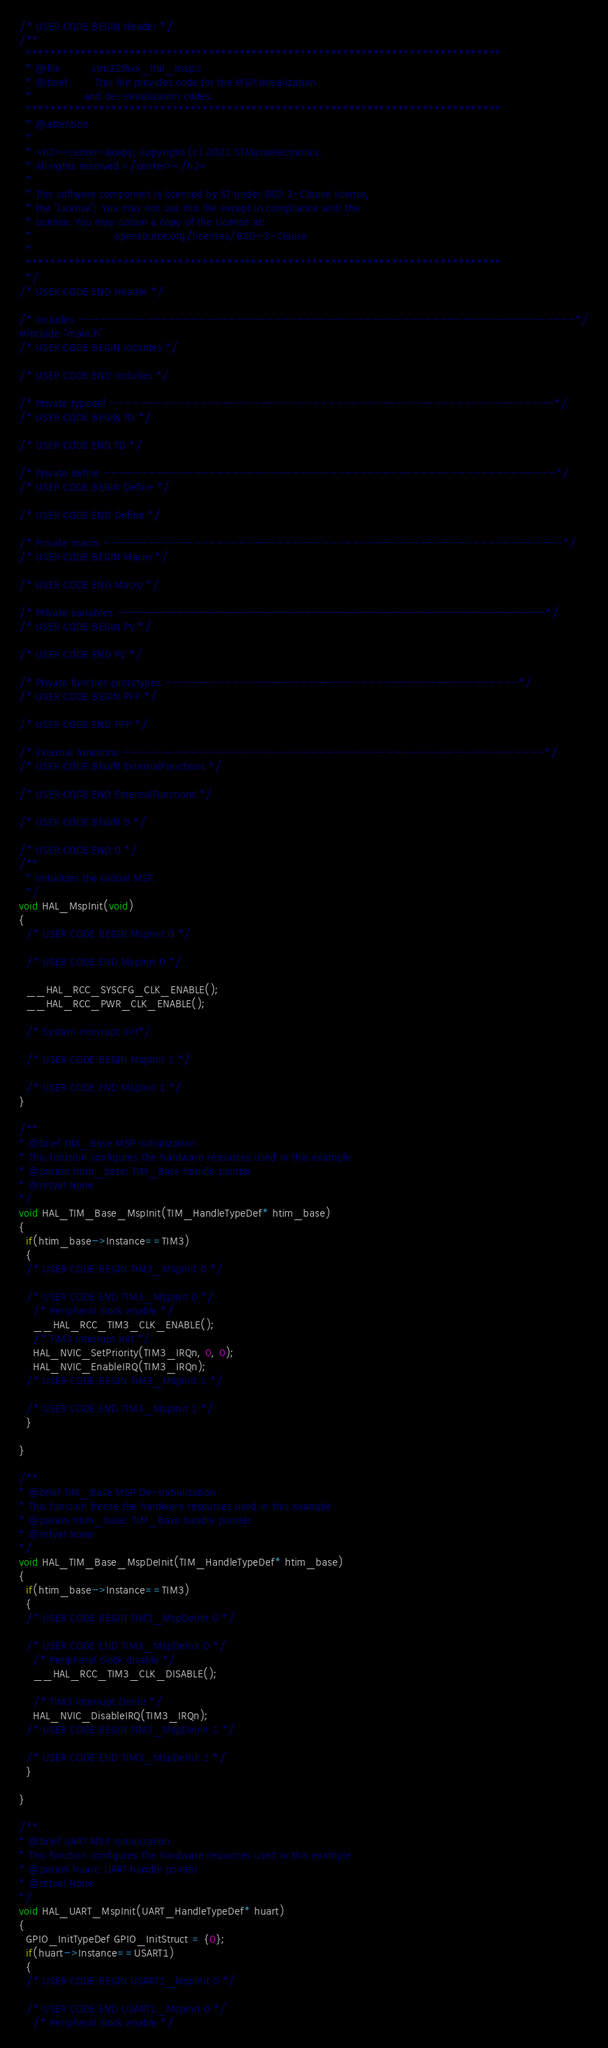<code> <loc_0><loc_0><loc_500><loc_500><_C_>/* USER CODE BEGIN Header */
/**
  ******************************************************************************
  * @file         stm32f4xx_hal_msp.c
  * @brief        This file provides code for the MSP Initialization
  *               and de-Initialization codes.
  ******************************************************************************
  * @attention
  *
  * <h2><center>&copy; Copyright (c) 2021 STMicroelectronics.
  * All rights reserved.</center></h2>
  *
  * This software component is licensed by ST under BSD 3-Clause license,
  * the "License"; You may not use this file except in compliance with the
  * License. You may obtain a copy of the License at:
  *                        opensource.org/licenses/BSD-3-Clause
  *
  ******************************************************************************
  */
/* USER CODE END Header */

/* Includes ------------------------------------------------------------------*/
#include "main.h"
/* USER CODE BEGIN Includes */

/* USER CODE END Includes */

/* Private typedef -----------------------------------------------------------*/
/* USER CODE BEGIN TD */

/* USER CODE END TD */

/* Private define ------------------------------------------------------------*/
/* USER CODE BEGIN Define */

/* USER CODE END Define */

/* Private macro -------------------------------------------------------------*/
/* USER CODE BEGIN Macro */

/* USER CODE END Macro */

/* Private variables ---------------------------------------------------------*/
/* USER CODE BEGIN PV */

/* USER CODE END PV */

/* Private function prototypes -----------------------------------------------*/
/* USER CODE BEGIN PFP */

/* USER CODE END PFP */

/* External functions --------------------------------------------------------*/
/* USER CODE BEGIN ExternalFunctions */

/* USER CODE END ExternalFunctions */

/* USER CODE BEGIN 0 */

/* USER CODE END 0 */
/**
  * Initializes the Global MSP.
  */
void HAL_MspInit(void)
{
  /* USER CODE BEGIN MspInit 0 */

  /* USER CODE END MspInit 0 */

  __HAL_RCC_SYSCFG_CLK_ENABLE();
  __HAL_RCC_PWR_CLK_ENABLE();

  /* System interrupt init*/

  /* USER CODE BEGIN MspInit 1 */

  /* USER CODE END MspInit 1 */
}

/**
* @brief TIM_Base MSP Initialization
* This function configures the hardware resources used in this example
* @param htim_base: TIM_Base handle pointer
* @retval None
*/
void HAL_TIM_Base_MspInit(TIM_HandleTypeDef* htim_base)
{
  if(htim_base->Instance==TIM3)
  {
  /* USER CODE BEGIN TIM3_MspInit 0 */

  /* USER CODE END TIM3_MspInit 0 */
    /* Peripheral clock enable */
    __HAL_RCC_TIM3_CLK_ENABLE();
    /* TIM3 interrupt Init */
    HAL_NVIC_SetPriority(TIM3_IRQn, 0, 0);
    HAL_NVIC_EnableIRQ(TIM3_IRQn);
  /* USER CODE BEGIN TIM3_MspInit 1 */

  /* USER CODE END TIM3_MspInit 1 */
  }

}

/**
* @brief TIM_Base MSP De-Initialization
* This function freeze the hardware resources used in this example
* @param htim_base: TIM_Base handle pointer
* @retval None
*/
void HAL_TIM_Base_MspDeInit(TIM_HandleTypeDef* htim_base)
{
  if(htim_base->Instance==TIM3)
  {
  /* USER CODE BEGIN TIM3_MspDeInit 0 */

  /* USER CODE END TIM3_MspDeInit 0 */
    /* Peripheral clock disable */
    __HAL_RCC_TIM3_CLK_DISABLE();

    /* TIM3 interrupt DeInit */
    HAL_NVIC_DisableIRQ(TIM3_IRQn);
  /* USER CODE BEGIN TIM3_MspDeInit 1 */

  /* USER CODE END TIM3_MspDeInit 1 */
  }

}

/**
* @brief UART MSP Initialization
* This function configures the hardware resources used in this example
* @param huart: UART handle pointer
* @retval None
*/
void HAL_UART_MspInit(UART_HandleTypeDef* huart)
{
  GPIO_InitTypeDef GPIO_InitStruct = {0};
  if(huart->Instance==USART1)
  {
  /* USER CODE BEGIN USART1_MspInit 0 */

  /* USER CODE END USART1_MspInit 0 */
    /* Peripheral clock enable */</code> 